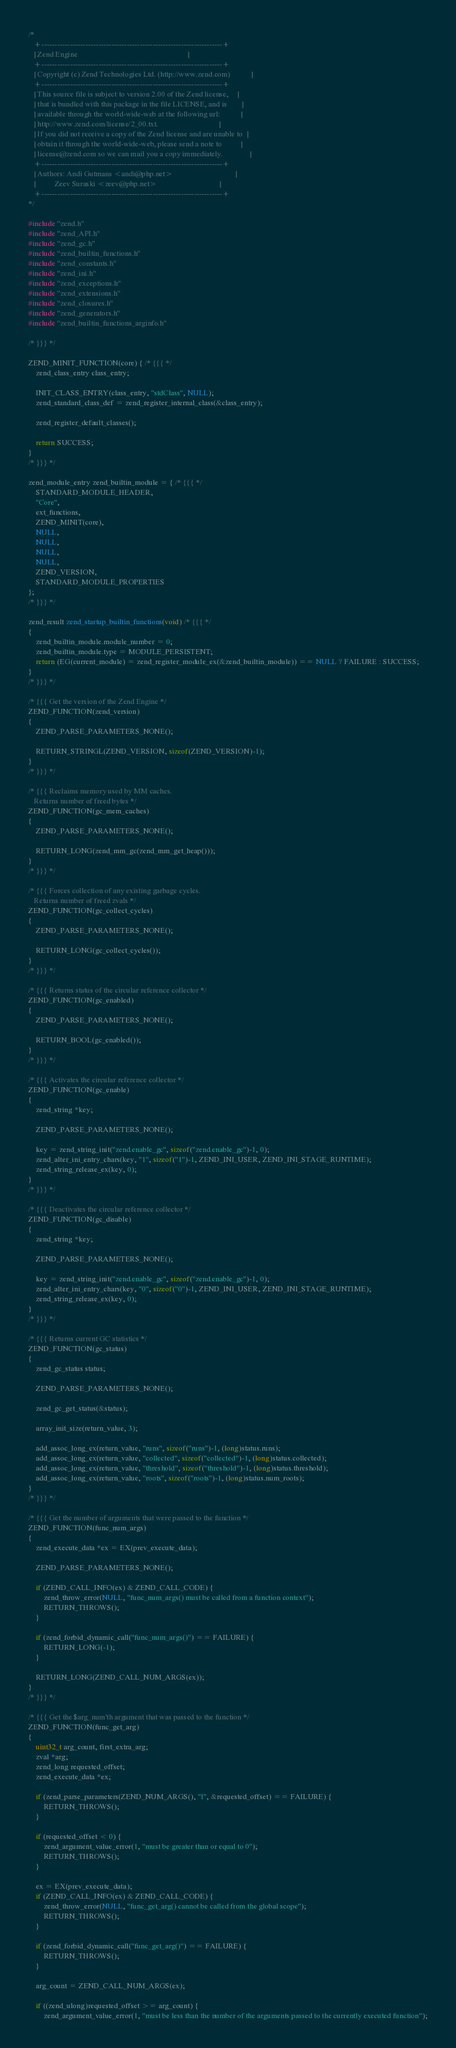Convert code to text. <code><loc_0><loc_0><loc_500><loc_500><_C_>/*
   +----------------------------------------------------------------------+
   | Zend Engine                                                          |
   +----------------------------------------------------------------------+
   | Copyright (c) Zend Technologies Ltd. (http://www.zend.com)           |
   +----------------------------------------------------------------------+
   | This source file is subject to version 2.00 of the Zend license,     |
   | that is bundled with this package in the file LICENSE, and is        |
   | available through the world-wide-web at the following url:           |
   | http://www.zend.com/license/2_00.txt.                                |
   | If you did not receive a copy of the Zend license and are unable to  |
   | obtain it through the world-wide-web, please send a note to          |
   | license@zend.com so we can mail you a copy immediately.              |
   +----------------------------------------------------------------------+
   | Authors: Andi Gutmans <andi@php.net>                                 |
   |          Zeev Suraski <zeev@php.net>                                 |
   +----------------------------------------------------------------------+
*/

#include "zend.h"
#include "zend_API.h"
#include "zend_gc.h"
#include "zend_builtin_functions.h"
#include "zend_constants.h"
#include "zend_ini.h"
#include "zend_exceptions.h"
#include "zend_extensions.h"
#include "zend_closures.h"
#include "zend_generators.h"
#include "zend_builtin_functions_arginfo.h"

/* }}} */

ZEND_MINIT_FUNCTION(core) { /* {{{ */
	zend_class_entry class_entry;

	INIT_CLASS_ENTRY(class_entry, "stdClass", NULL);
	zend_standard_class_def = zend_register_internal_class(&class_entry);

	zend_register_default_classes();

	return SUCCESS;
}
/* }}} */

zend_module_entry zend_builtin_module = { /* {{{ */
	STANDARD_MODULE_HEADER,
	"Core",
	ext_functions,
	ZEND_MINIT(core),
	NULL,
	NULL,
	NULL,
	NULL,
	ZEND_VERSION,
	STANDARD_MODULE_PROPERTIES
};
/* }}} */

zend_result zend_startup_builtin_functions(void) /* {{{ */
{
	zend_builtin_module.module_number = 0;
	zend_builtin_module.type = MODULE_PERSISTENT;
	return (EG(current_module) = zend_register_module_ex(&zend_builtin_module)) == NULL ? FAILURE : SUCCESS;
}
/* }}} */

/* {{{ Get the version of the Zend Engine */
ZEND_FUNCTION(zend_version)
{
	ZEND_PARSE_PARAMETERS_NONE();

	RETURN_STRINGL(ZEND_VERSION, sizeof(ZEND_VERSION)-1);
}
/* }}} */

/* {{{ Reclaims memory used by MM caches.
   Returns number of freed bytes */
ZEND_FUNCTION(gc_mem_caches)
{
	ZEND_PARSE_PARAMETERS_NONE();

	RETURN_LONG(zend_mm_gc(zend_mm_get_heap()));
}
/* }}} */

/* {{{ Forces collection of any existing garbage cycles.
   Returns number of freed zvals */
ZEND_FUNCTION(gc_collect_cycles)
{
	ZEND_PARSE_PARAMETERS_NONE();

	RETURN_LONG(gc_collect_cycles());
}
/* }}} */

/* {{{ Returns status of the circular reference collector */
ZEND_FUNCTION(gc_enabled)
{
	ZEND_PARSE_PARAMETERS_NONE();

	RETURN_BOOL(gc_enabled());
}
/* }}} */

/* {{{ Activates the circular reference collector */
ZEND_FUNCTION(gc_enable)
{
	zend_string *key;

	ZEND_PARSE_PARAMETERS_NONE();

	key = zend_string_init("zend.enable_gc", sizeof("zend.enable_gc")-1, 0);
	zend_alter_ini_entry_chars(key, "1", sizeof("1")-1, ZEND_INI_USER, ZEND_INI_STAGE_RUNTIME);
	zend_string_release_ex(key, 0);
}
/* }}} */

/* {{{ Deactivates the circular reference collector */
ZEND_FUNCTION(gc_disable)
{
	zend_string *key;

	ZEND_PARSE_PARAMETERS_NONE();

	key = zend_string_init("zend.enable_gc", sizeof("zend.enable_gc")-1, 0);
	zend_alter_ini_entry_chars(key, "0", sizeof("0")-1, ZEND_INI_USER, ZEND_INI_STAGE_RUNTIME);
	zend_string_release_ex(key, 0);
}
/* }}} */

/* {{{ Returns current GC statistics */
ZEND_FUNCTION(gc_status)
{
	zend_gc_status status;

	ZEND_PARSE_PARAMETERS_NONE();

	zend_gc_get_status(&status);

	array_init_size(return_value, 3);

	add_assoc_long_ex(return_value, "runs", sizeof("runs")-1, (long)status.runs);
	add_assoc_long_ex(return_value, "collected", sizeof("collected")-1, (long)status.collected);
	add_assoc_long_ex(return_value, "threshold", sizeof("threshold")-1, (long)status.threshold);
	add_assoc_long_ex(return_value, "roots", sizeof("roots")-1, (long)status.num_roots);
}
/* }}} */

/* {{{ Get the number of arguments that were passed to the function */
ZEND_FUNCTION(func_num_args)
{
	zend_execute_data *ex = EX(prev_execute_data);

	ZEND_PARSE_PARAMETERS_NONE();

	if (ZEND_CALL_INFO(ex) & ZEND_CALL_CODE) {
		zend_throw_error(NULL, "func_num_args() must be called from a function context");
		RETURN_THROWS();
	}

	if (zend_forbid_dynamic_call("func_num_args()") == FAILURE) {
		RETURN_LONG(-1);
	}

	RETURN_LONG(ZEND_CALL_NUM_ARGS(ex));
}
/* }}} */

/* {{{ Get the $arg_num'th argument that was passed to the function */
ZEND_FUNCTION(func_get_arg)
{
	uint32_t arg_count, first_extra_arg;
	zval *arg;
	zend_long requested_offset;
	zend_execute_data *ex;

	if (zend_parse_parameters(ZEND_NUM_ARGS(), "l", &requested_offset) == FAILURE) {
		RETURN_THROWS();
	}

	if (requested_offset < 0) {
		zend_argument_value_error(1, "must be greater than or equal to 0");
		RETURN_THROWS();
	}

	ex = EX(prev_execute_data);
	if (ZEND_CALL_INFO(ex) & ZEND_CALL_CODE) {
		zend_throw_error(NULL, "func_get_arg() cannot be called from the global scope");
		RETURN_THROWS();
	}

	if (zend_forbid_dynamic_call("func_get_arg()") == FAILURE) {
		RETURN_THROWS();
	}

	arg_count = ZEND_CALL_NUM_ARGS(ex);

	if ((zend_ulong)requested_offset >= arg_count) {
		zend_argument_value_error(1, "must be less than the number of the arguments passed to the currently executed function");</code> 